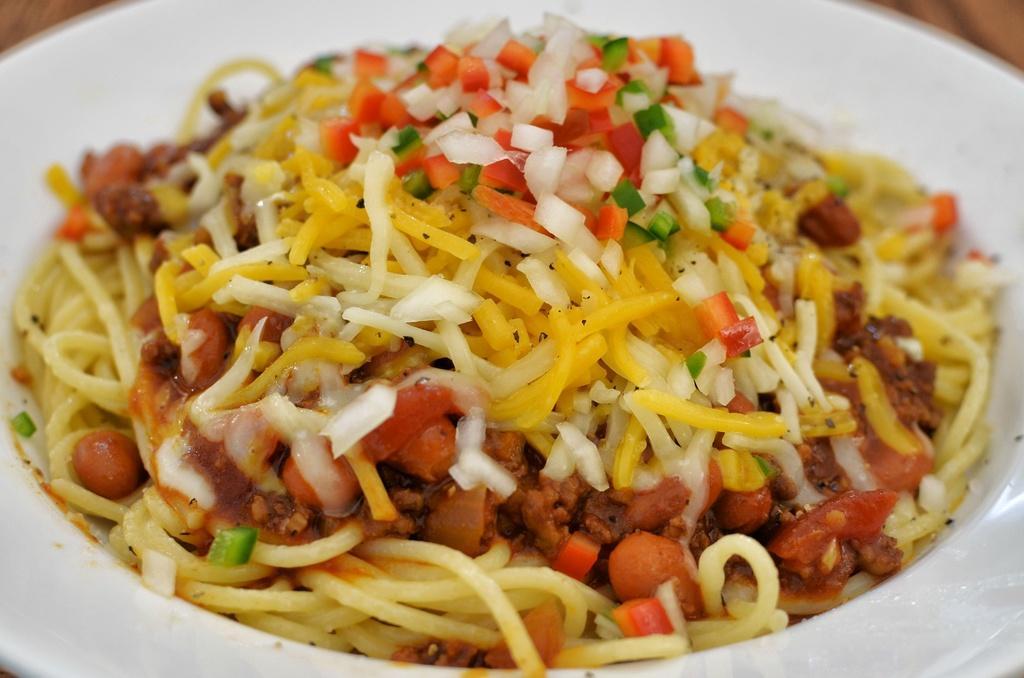Please provide a concise description of this image. In the picture there is a plate with the food item present. 